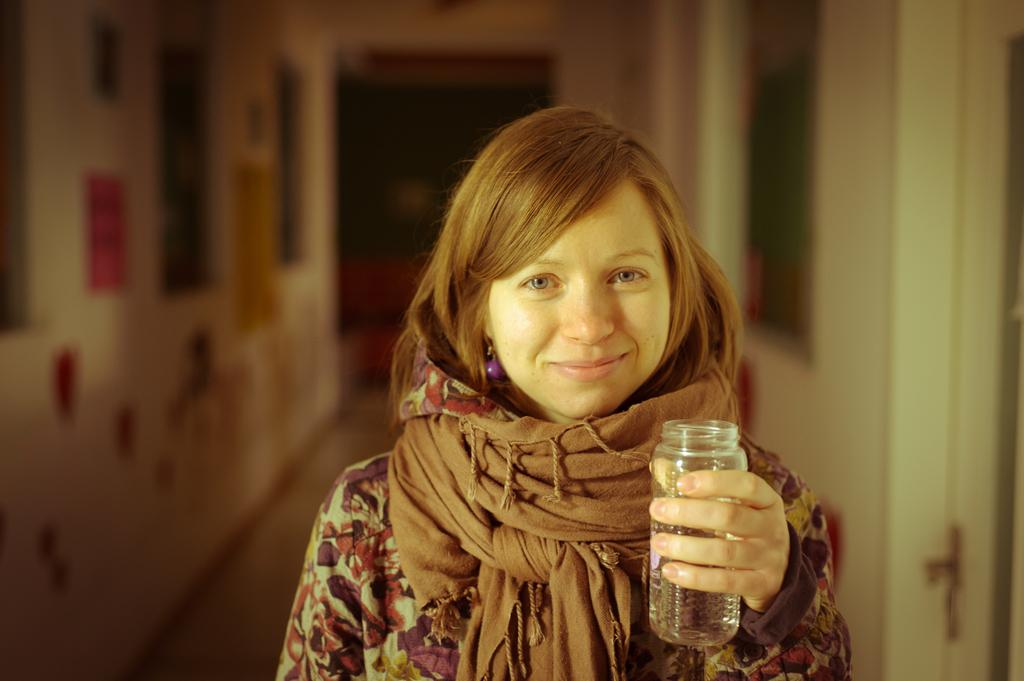Who is the main subject in the image? There is a woman in the center of the image. What is the woman holding in her hand? The woman is holding a jar in her hand. What can be seen on both sides of the image? There are walls on both sides of the image. What architectural feature is present on the right side of the image? There is a door on the right side of the image. What type of discussion is taking place in the image? There is no discussion taking place in the image; it only shows a woman holding a jar. Can you describe the bushes visible in the image? There are no bushes present in the image. 